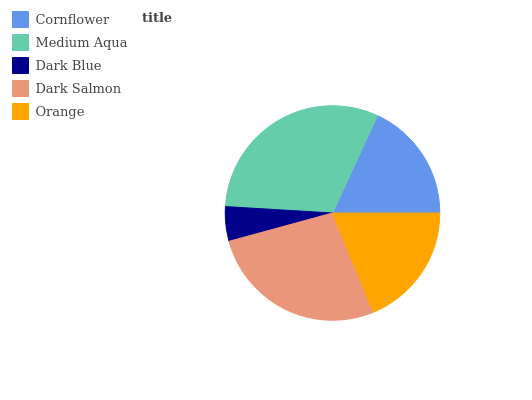Is Dark Blue the minimum?
Answer yes or no. Yes. Is Medium Aqua the maximum?
Answer yes or no. Yes. Is Medium Aqua the minimum?
Answer yes or no. No. Is Dark Blue the maximum?
Answer yes or no. No. Is Medium Aqua greater than Dark Blue?
Answer yes or no. Yes. Is Dark Blue less than Medium Aqua?
Answer yes or no. Yes. Is Dark Blue greater than Medium Aqua?
Answer yes or no. No. Is Medium Aqua less than Dark Blue?
Answer yes or no. No. Is Orange the high median?
Answer yes or no. Yes. Is Orange the low median?
Answer yes or no. Yes. Is Cornflower the high median?
Answer yes or no. No. Is Medium Aqua the low median?
Answer yes or no. No. 